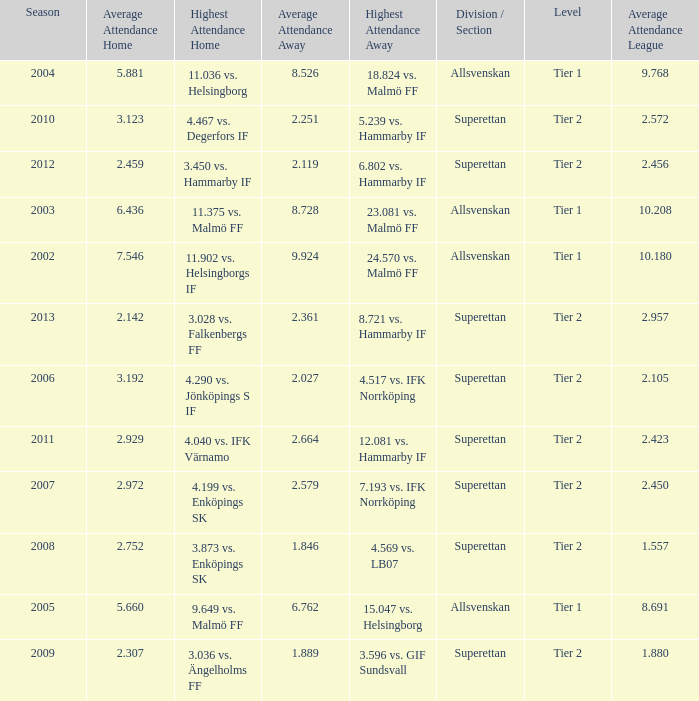How many season have an average attendance league of 2.456? 2012.0. 